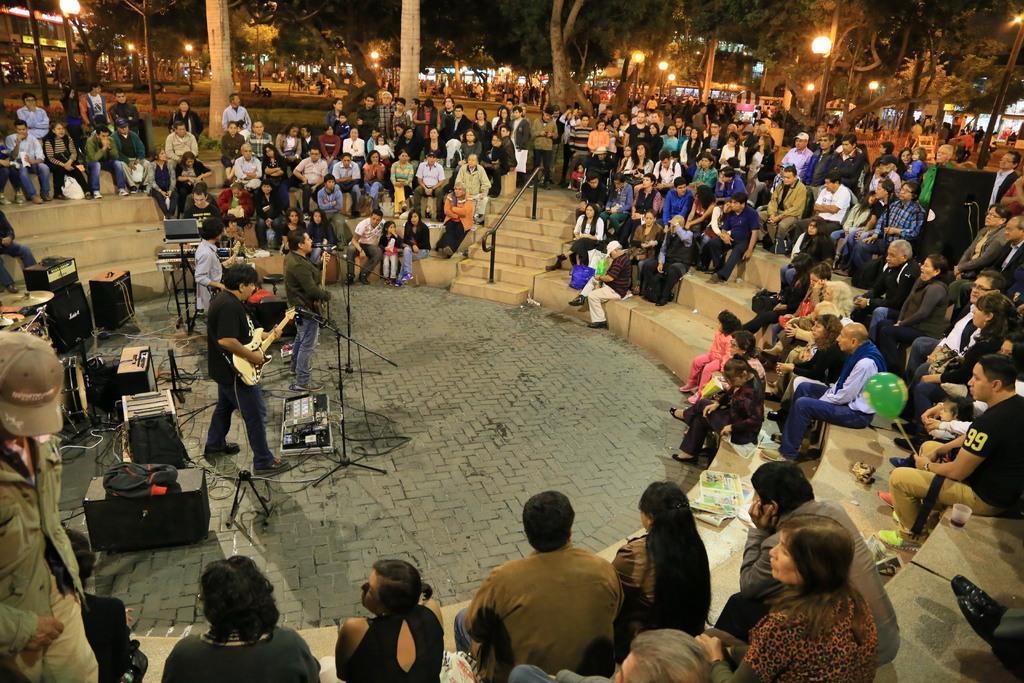Please provide a concise description of this image. In this picture there are three person were playing guitar, standing near the mic. On the right we can see many peoples were sitting on the stairs. In the background we can see another person standing near to the street lights. On the right background we can see the buildings. 